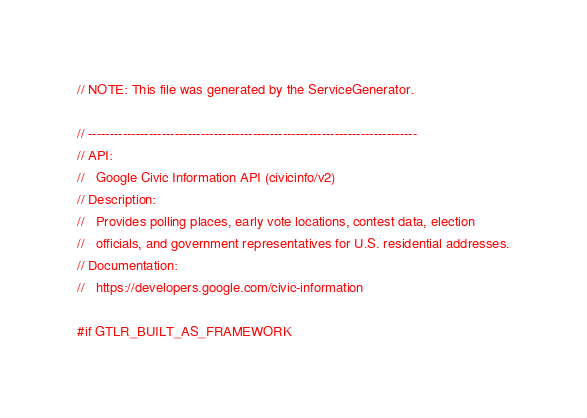<code> <loc_0><loc_0><loc_500><loc_500><_C_>// NOTE: This file was generated by the ServiceGenerator.

// ----------------------------------------------------------------------------
// API:
//   Google Civic Information API (civicinfo/v2)
// Description:
//   Provides polling places, early vote locations, contest data, election
//   officials, and government representatives for U.S. residential addresses.
// Documentation:
//   https://developers.google.com/civic-information

#if GTLR_BUILT_AS_FRAMEWORK</code> 